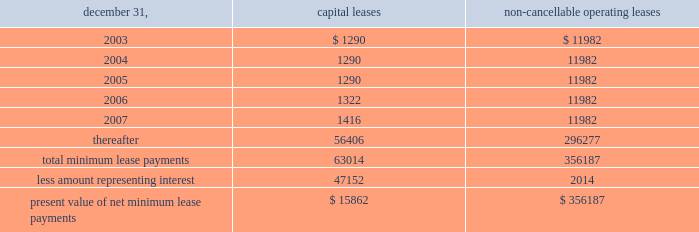N o t e s t o c o n s o l i d a t e d f i n a n c i a l s t a t e m e n t s ( c o n t i n u e d ) the realization of this investment gain ( $ 5624 net of the award ) .
This award , which will be paid out over a three-year period , is presented as deferred compensation award on the balance sheet .
As of december 31 , 2002 , $ 1504 had been paid against this compensation award .
401 ( k ) plan during august 1997 , the company implemented a 401 ( k ) savings/retirement plan ( the 201c401 ( k ) plan 201d ) to cover eligible employees of the company and any designated affiliate .
The 401 ( k ) plan permits eligible employees of the company to defer up to 15% ( 15 % ) of their annual compensation , subject to cer- tain limitations imposed by the code .
The employees 2019 elec- tive deferrals are immediately vested and non-forfeitable upon contribution to the 401 ( k ) plan .
During 2000 , the company amended its 401 ( k ) plan to include a matching contribution , subject to erisa limitations , equal to 50% ( 50 % ) of the first 4% ( 4 % ) of annual compensation deferred by an employee .
For the years ended december 31 , 2002 , 2001 and 2000 , the company made matching contributions of $ 140 , $ 116 and $ 54 , respectively .
18 .
Commitments and contingencies the company and the operating partnership are not presently involved in any material litigation nor , to their knowledge , is any material litigation threatened against them or their properties , other than routine litigation arising in the ordinary course of business .
Management believes the costs , if any , incurred by the company and the operating partnership related to this litigation will not materially affect the financial position , operating results or liquidity of the company and the operating partnership .
On october 24 , 2001 , an accident occurred at 215 park avenue south , a property which the company manages , but does not own .
Personal injury claims have been filed against the company and others by 11 persons .
The company believes that there is sufficient insurance coverage to cover the cost of such claims , as well as any other personal injury or property claims which may arise .
The company has entered into employment agreements with certain executives .
Six executives have employment agreements which expire between november 2003 and december 2007 .
The cash based compensation associated with these employment agreements totals approximately $ 2125 for 2003 .
During march 1998 , the company acquired an operating sub-leasehold position at 420 lexington avenue .
The oper- ating sub-leasehold position requires annual ground lease payments totaling $ 6000 and sub-leasehold position pay- ments totaling $ 1100 ( excluding an operating sub-lease position purchased january 1999 ) .
The ground lease and sub-leasehold positions expire 2008 .
The company may extend the positions through 2029 at market rents .
The property located at 1140 avenue of the americas operates under a net ground lease ( $ 348 annually ) with a term expiration date of 2016 and with an option to renew for an additional 50 years .
The property located at 711 third avenue operates under an operating sub-lease which expires in 2083 .
Under the sub- lease , the company is responsible for ground rent payments of $ 1600 annually which increased to $ 3100 in july 2001 and will continue for the next ten years .
The ground rent is reset after year ten based on the estimated fair market value of the property .
In april 1988 , the sl green predecessor entered into a lease agreement for property at 673 first avenue in new york city , which has been capitalized for financial statement purposes .
Land was estimated to be approximately 70% ( 70 % ) of the fair market value of the property .
The portion of the lease attributed to land is classified as an operating lease and the remainder as a capital lease .
The initial lease term is 49 years with an option for an additional 26 years .
Beginning in lease years 11 and 25 , the lessor is entitled to additional rent as defined by the lease agreement .
The company continues to lease the 673 first avenue prop- erty which has been classified as a capital lease with a cost basis of $ 12208 and cumulative amortization of $ 3579 and $ 3306 at december 31 , 2002 and 2001 , respectively .
The fol- lowing is a schedule of future minimum lease payments under capital leases and noncancellable operating leases with initial terms in excess of one year as of december 31 , 2002 .
Non-cancellable operating december 31 , capital leases leases .
19 .
Financial instruments : derivatives and hedging financial accounting standards board 2019s statement no .
133 , 201caccounting for derivative instruments and hedging activities , 201d ( 201csfas 133 201d ) which became effective january 1 , 2001 requires the company to recognize all derivatives on the balance sheet at fair value .
Derivatives that are not hedges must be adjusted to fair value through income .
If a derivative is a hedge , depending on the nature of the hedge , f i f t y - t w o s l g r e e n r e a l t y c o r p . .
What percent of the capital lease payments are due in 2003? 
Computations: (1290 / 63014)
Answer: 0.02047. 